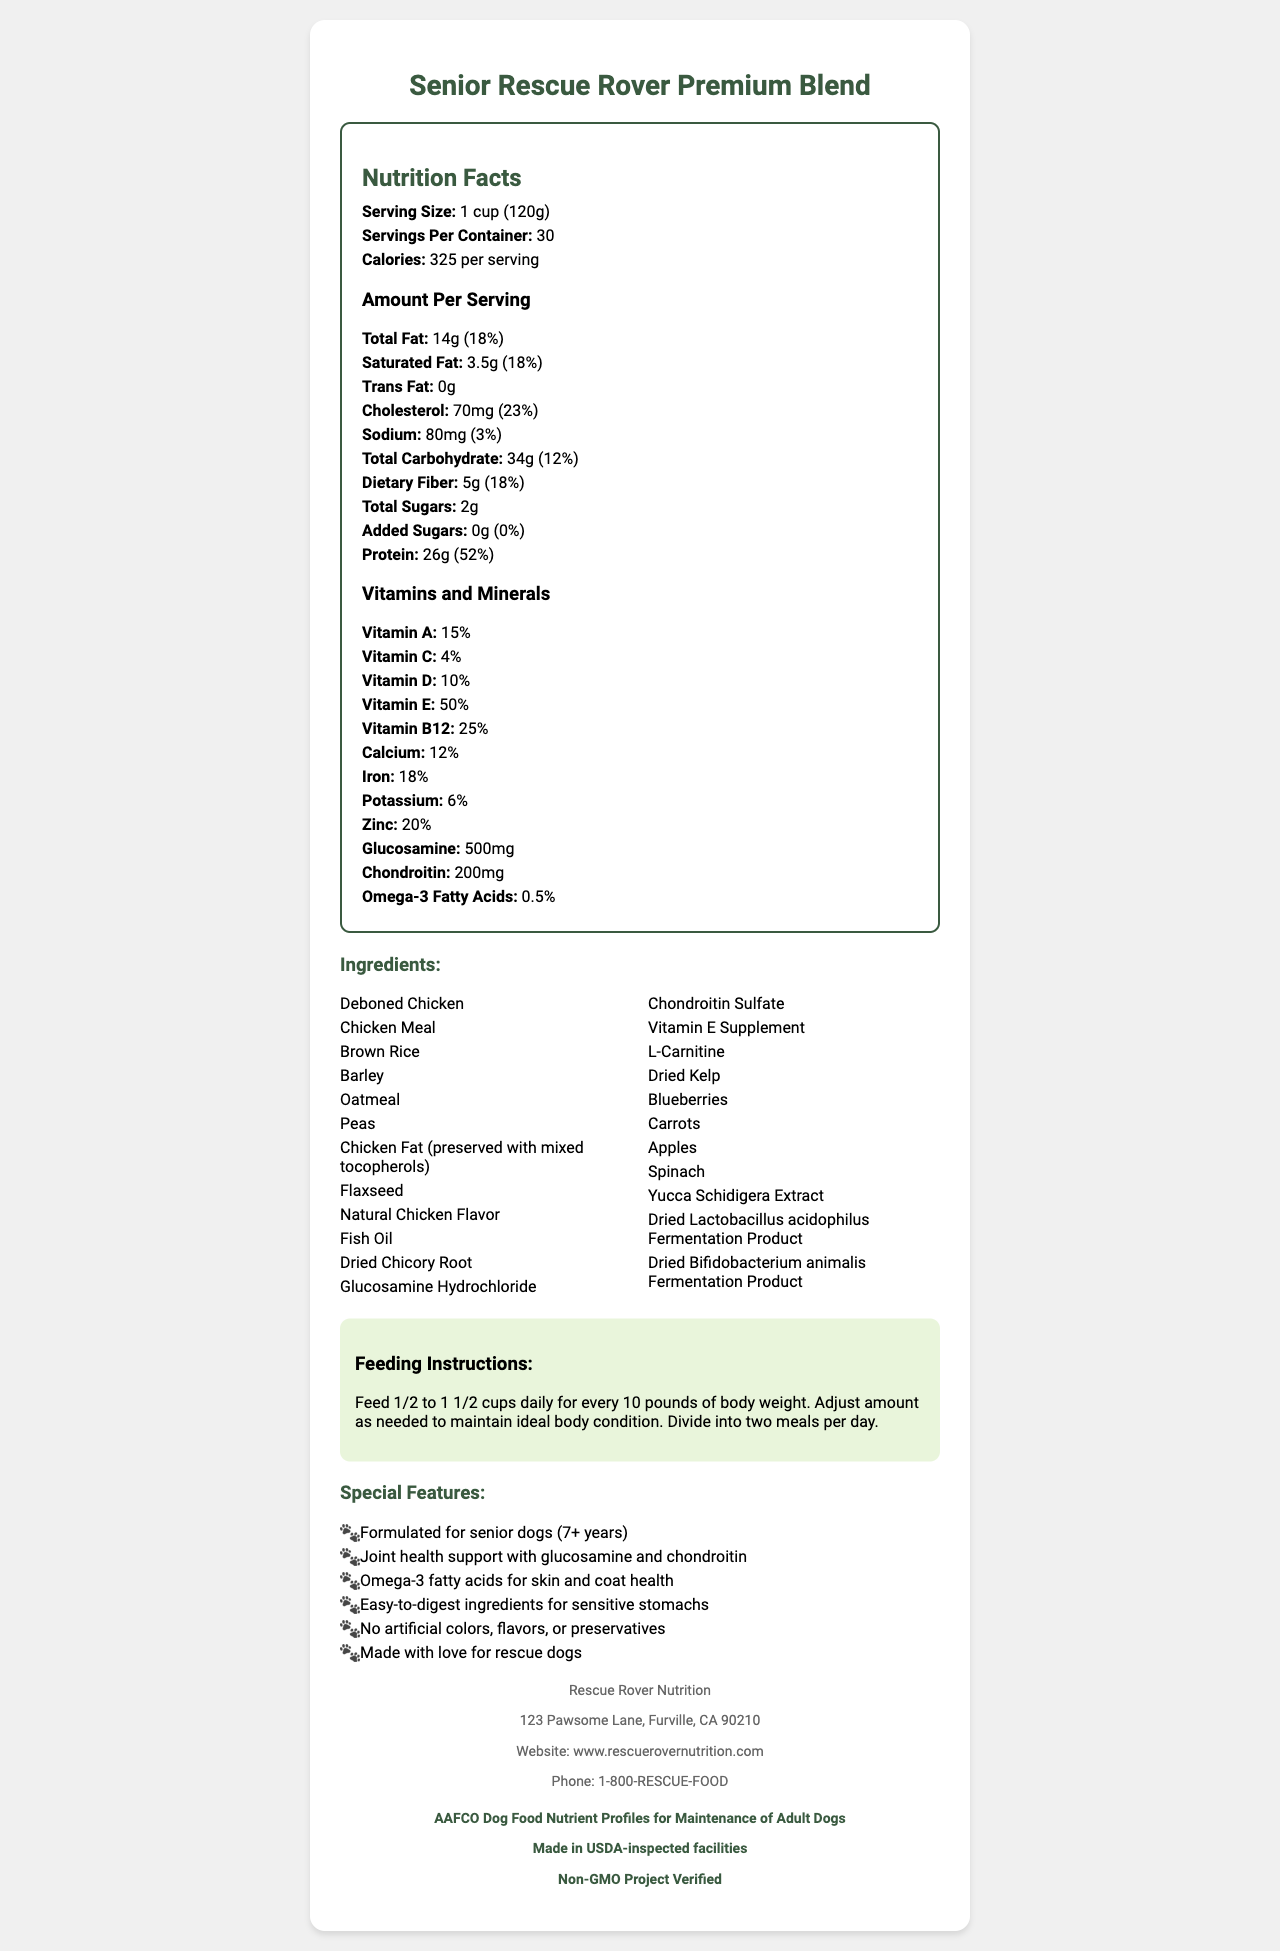what is the serving size for the dog food? The serving size is stated as "1 cup (120g)" in the Nutrition Facts section.
Answer: 1 cup (120g) how many servings are there per container? The servings per container are listed as 30 in the Nutrition Facts section.
Answer: 30 how many calories are there per serving? The calories per serving are listed as 325 in the Nutrition Facts section.
Answer: 325 what is the amount of dietary fiber per serving? The dietary fiber amount per serving is listed as 5g in the Macronutrients section.
Answer: 5g what is the daily value percentage of protein per serving? The daily value percentage of protein per serving is listed as 52% in the Macronutrients section.
Answer: 52% which of the following is NOT listed as an ingredient in the dog food? A. Deboned Chicken B. Brown Rice C. Corn D. Blueberries The ingredients list includes Deboned Chicken, Brown Rice, and Blueberries, but not Corn.
Answer: C which vitamin has the highest daily value percentage? A. Vitamin A B. Vitamin C C. Vitamin E D. Vitamin B12 Vitamin E has the highest daily value percentage at 50%.
Answer: C is the dog food made with artificial colors, flavors, or preservatives? The special features list states that the dog food contains no artificial colors, flavors, or preservatives.
Answer: No does the dog food contain glucosamine? The Vitamins and Minerals section lists glucosamine at 500mg.
Answer: Yes summarize the main features and nutritional content of the dog food. The document summarizes the product's intended use for senior rescue dogs, lists key benefits like joint support and easy digestion, details primary ingredients, and highlights manufacturer details and certifications.
Answer: "Senior Rescue Rover Premium Blend" is a premium dog food designed for senior rescue dogs (7+ years). It supports joint health with glucosamine and chondroitin, promotes skin and coat health with omega-3 fatty acids, and uses easy-to-digest ingredients for sensitive stomachs. The food contains no artificial colors, flavors, or preservatives and is made with high-quality ingredients such as deboned chicken, brown rice, barley, and oatmeal. The product meets AAFCO Dog Food Nutrient Profiles for Maintenance of Adult Dogs and is made in USDA-inspected facilities, is non-GMO project verified. what percentage of iron is in one serving? The daily value percentage of iron per serving is listed as 18% in the Vitamins and Minerals section.
Answer: 18% what is the recommended feeding amount for a 20-pound dog? The feeding instructions recommend feeding 1/2 to 1 1/2 cups daily for every 10 pounds of body weight.
Answer: 1 to 3 cups daily what is the company name that manufactures the dog food? The manufacturer info lists the company name as Rescue Rover Nutrition.
Answer: Rescue Rover Nutrition where is the company located? The manufacturer info lists the address as 123 Pawsome Lane, Furville, CA 90210.
Answer: 123 Pawsome Lane, Furville, CA 90210 how many grams of protein are there per serving? The protein amount per serving is listed as 26g in the Macronutrients section.
Answer: 26g what is the moisture content of the dog food? The document does not provide information on the moisture content of the dog food.
Answer: Not enough information 